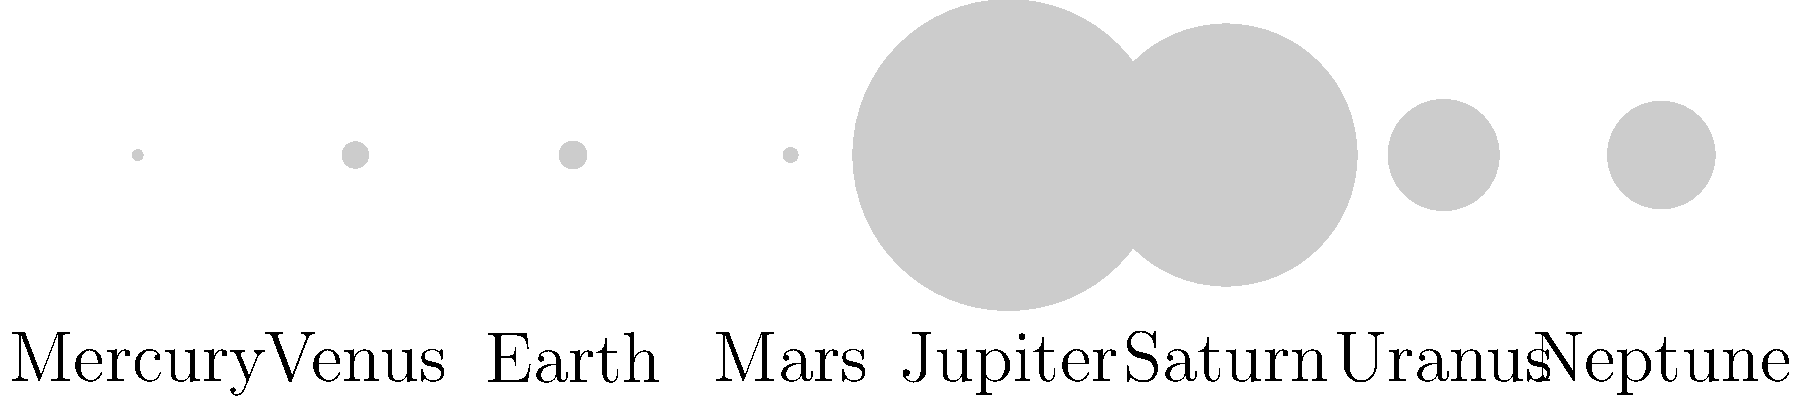In the scaled diagram of our solar system's planets, which planet appears to be approximately twice the size of Earth? To answer this question, we need to analyze the relative sizes of the planets in the diagram:

1. Observe that Earth is labeled and has a specific size in the diagram.
2. Compare the size of Earth to the other planets visually.
3. Jupiter and Saturn are clearly much larger than Earth.
4. Uranus and Neptune are noticeably larger than Earth, but not as large as Jupiter or Saturn.
5. Mercury, Venus, and Mars are smaller than Earth.
6. Among the larger planets, Saturn appears to be closest to twice the size of Earth.

To verify this observation:
1. Earth's relative size is given as 1 in the data.
2. Saturn's relative size is given as 9.45.
3. The ratio of Saturn to Earth is 9.45 / 1 ≈ 9.45.

While this is not exactly twice the size, in the scaled diagram, Saturn appears to be the planet closest to being twice the size of Earth among the options available.
Answer: Saturn 